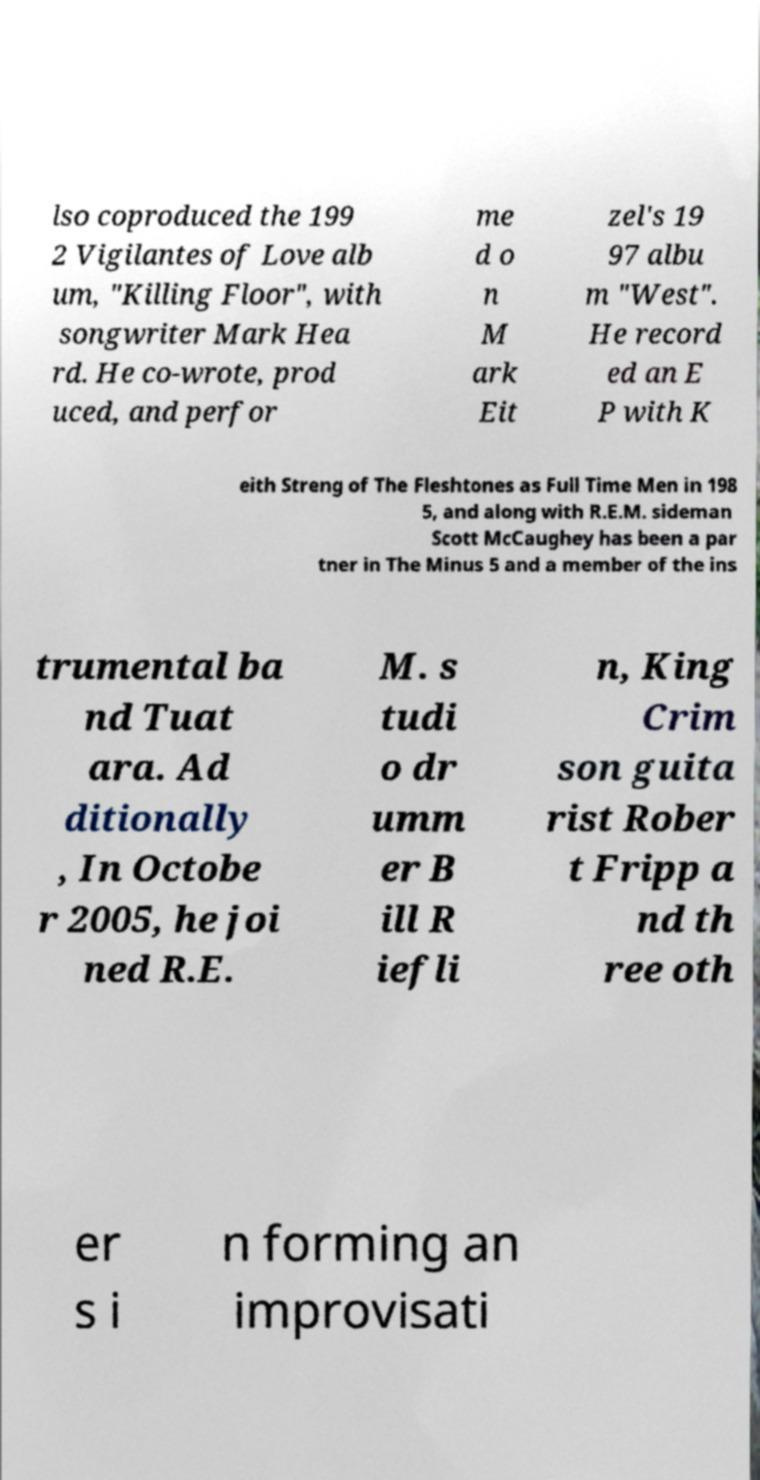Could you assist in decoding the text presented in this image and type it out clearly? lso coproduced the 199 2 Vigilantes of Love alb um, "Killing Floor", with songwriter Mark Hea rd. He co-wrote, prod uced, and perfor me d o n M ark Eit zel's 19 97 albu m "West". He record ed an E P with K eith Streng of The Fleshtones as Full Time Men in 198 5, and along with R.E.M. sideman Scott McCaughey has been a par tner in The Minus 5 and a member of the ins trumental ba nd Tuat ara. Ad ditionally , In Octobe r 2005, he joi ned R.E. M. s tudi o dr umm er B ill R iefli n, King Crim son guita rist Rober t Fripp a nd th ree oth er s i n forming an improvisati 